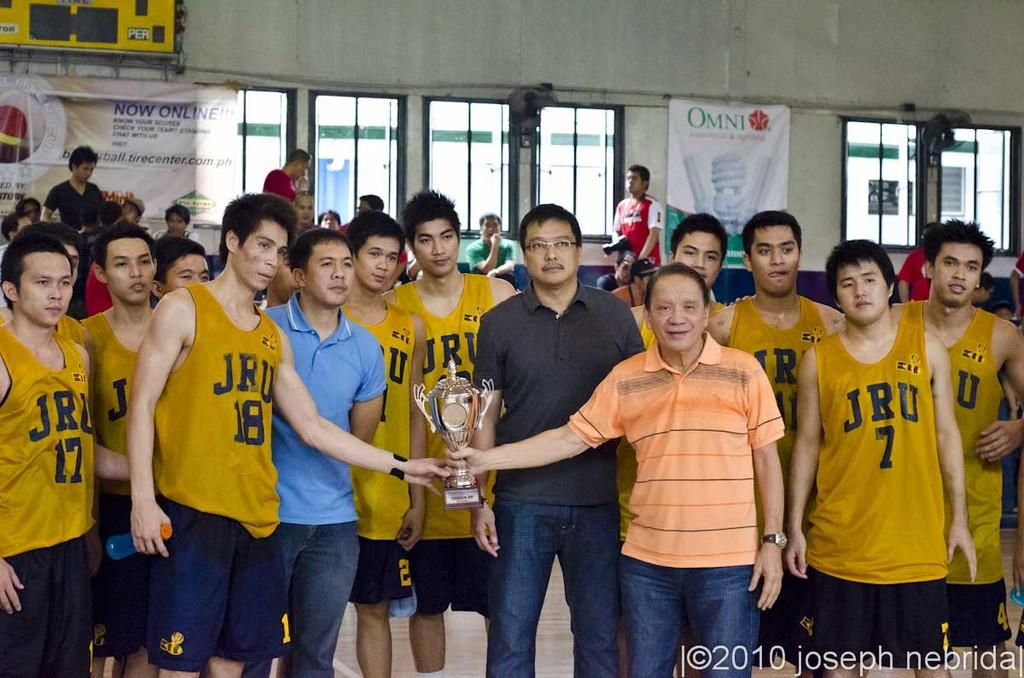<image>
Relay a brief, clear account of the picture shown. JRU TEAM IN A GYM WITH ONE TEAM MEMBER AND MAN IN ORANGE POLO HOLDING ONTO TROPHY. 